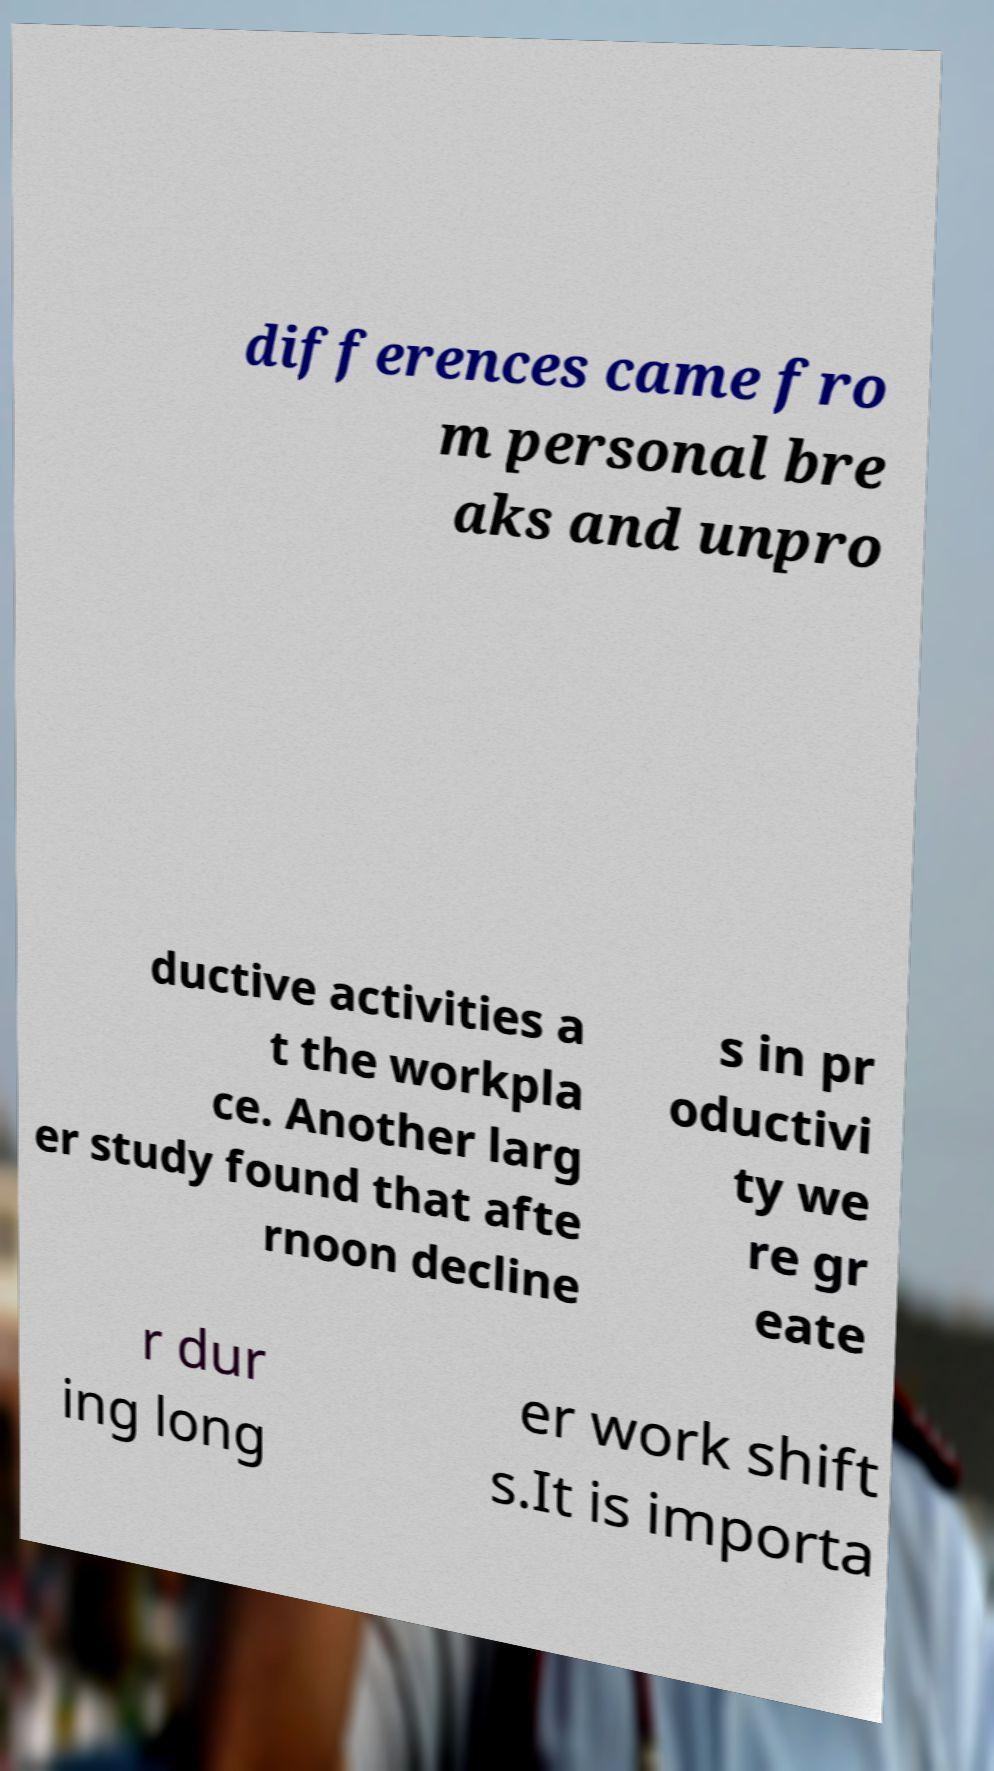I need the written content from this picture converted into text. Can you do that? differences came fro m personal bre aks and unpro ductive activities a t the workpla ce. Another larg er study found that afte rnoon decline s in pr oductivi ty we re gr eate r dur ing long er work shift s.It is importa 